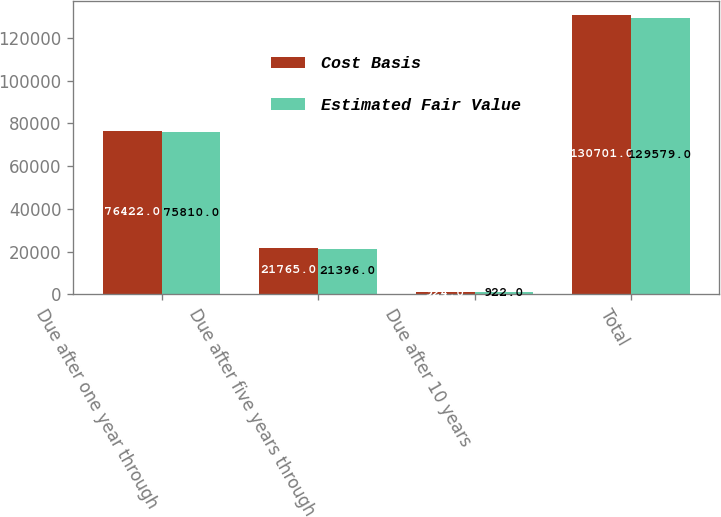<chart> <loc_0><loc_0><loc_500><loc_500><stacked_bar_chart><ecel><fcel>Due after one year through<fcel>Due after five years through<fcel>Due after 10 years<fcel>Total<nl><fcel>Cost Basis<fcel>76422<fcel>21765<fcel>924<fcel>130701<nl><fcel>Estimated Fair Value<fcel>75810<fcel>21396<fcel>922<fcel>129579<nl></chart> 